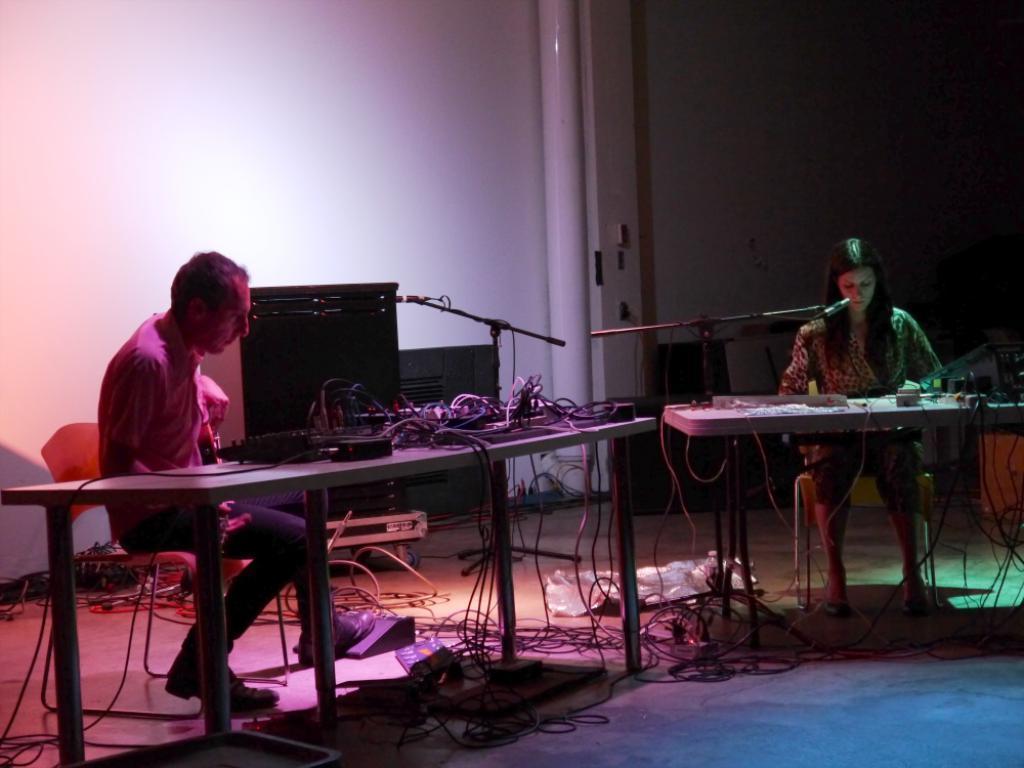Could you give a brief overview of what you see in this image? In this picture we can see a man and a woman sitting on chairs in front of tables, there are some switch boards and wires on these tables, we can see microphones in front of them, in the background there is a wall, there is a box in the background, we can see wires at the bottom. 